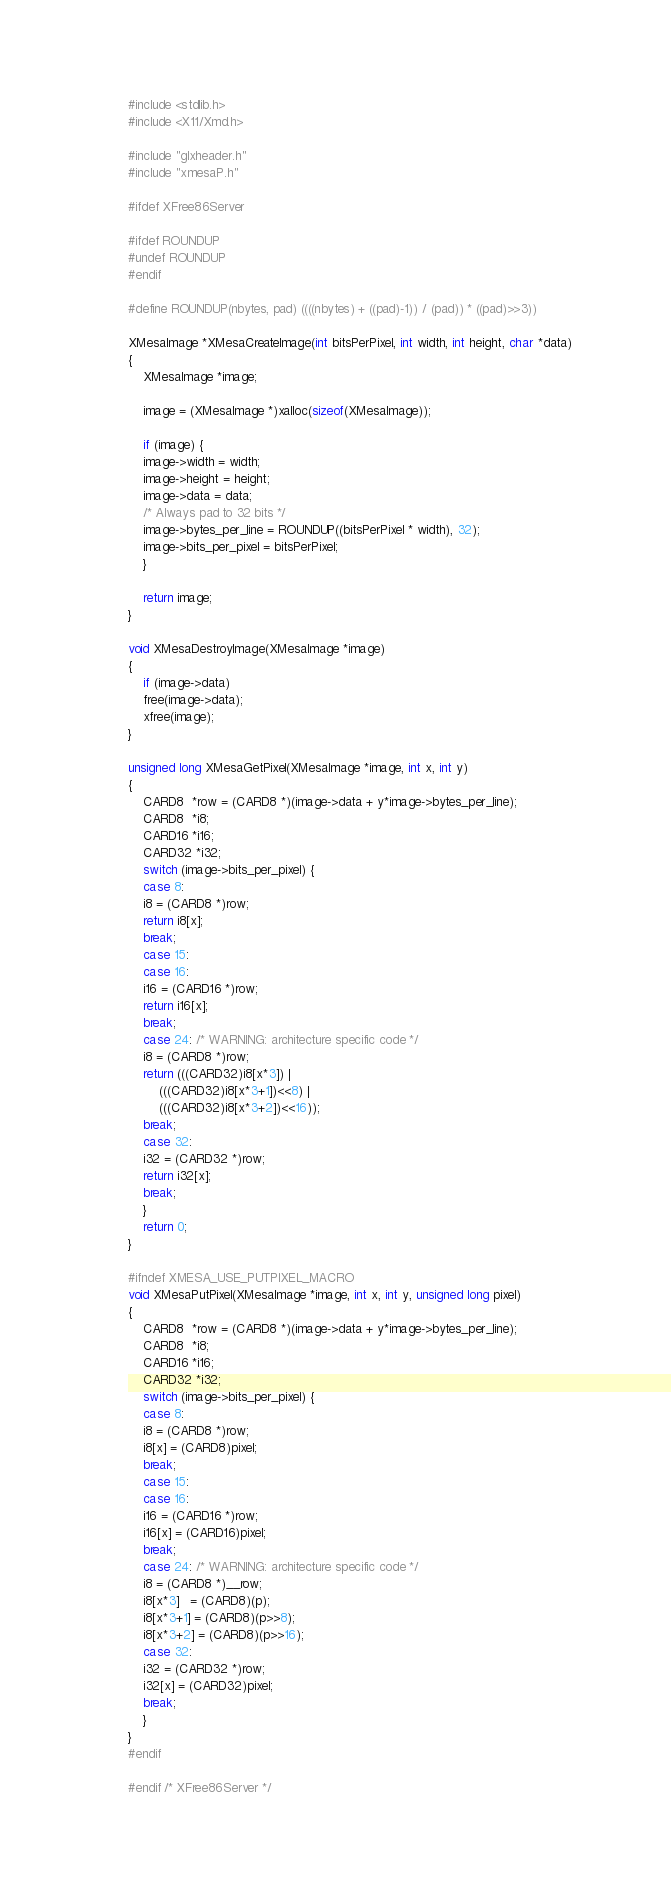Convert code to text. <code><loc_0><loc_0><loc_500><loc_500><_C_>
#include <stdlib.h>
#include <X11/Xmd.h>

#include "glxheader.h"
#include "xmesaP.h"

#ifdef XFree86Server

#ifdef ROUNDUP
#undef ROUNDUP
#endif

#define ROUNDUP(nbytes, pad) ((((nbytes) + ((pad)-1)) / (pad)) * ((pad)>>3))

XMesaImage *XMesaCreateImage(int bitsPerPixel, int width, int height, char *data)
{
    XMesaImage *image;

    image = (XMesaImage *)xalloc(sizeof(XMesaImage));

    if (image) {
	image->width = width;
	image->height = height;
	image->data = data;
	/* Always pad to 32 bits */
	image->bytes_per_line = ROUNDUP((bitsPerPixel * width), 32);
	image->bits_per_pixel = bitsPerPixel;
    }

    return image;
}

void XMesaDestroyImage(XMesaImage *image)
{
    if (image->data)
	free(image->data);
    xfree(image);
}

unsigned long XMesaGetPixel(XMesaImage *image, int x, int y)
{
    CARD8  *row = (CARD8 *)(image->data + y*image->bytes_per_line);
    CARD8  *i8;
    CARD16 *i16;
    CARD32 *i32;
    switch (image->bits_per_pixel) {
    case 8:
	i8 = (CARD8 *)row;
	return i8[x];
	break;
    case 15:
    case 16:
	i16 = (CARD16 *)row;
	return i16[x];
	break;
    case 24: /* WARNING: architecture specific code */
	i8 = (CARD8 *)row;
	return (((CARD32)i8[x*3]) |
		(((CARD32)i8[x*3+1])<<8) |
		(((CARD32)i8[x*3+2])<<16));
	break;
    case 32:
	i32 = (CARD32 *)row;
	return i32[x];
	break;
    }
    return 0;
}

#ifndef XMESA_USE_PUTPIXEL_MACRO
void XMesaPutPixel(XMesaImage *image, int x, int y, unsigned long pixel)
{
    CARD8  *row = (CARD8 *)(image->data + y*image->bytes_per_line);
    CARD8  *i8;
    CARD16 *i16;
    CARD32 *i32;
    switch (image->bits_per_pixel) {
    case 8:
	i8 = (CARD8 *)row;
	i8[x] = (CARD8)pixel;
	break;
    case 15:
    case 16:
	i16 = (CARD16 *)row;
	i16[x] = (CARD16)pixel;
	break;
    case 24: /* WARNING: architecture specific code */
	i8 = (CARD8 *)__row;
	i8[x*3]   = (CARD8)(p);
	i8[x*3+1] = (CARD8)(p>>8);
	i8[x*3+2] = (CARD8)(p>>16);
    case 32:
	i32 = (CARD32 *)row;
	i32[x] = (CARD32)pixel;
	break;
    }
}
#endif

#endif /* XFree86Server */
</code> 